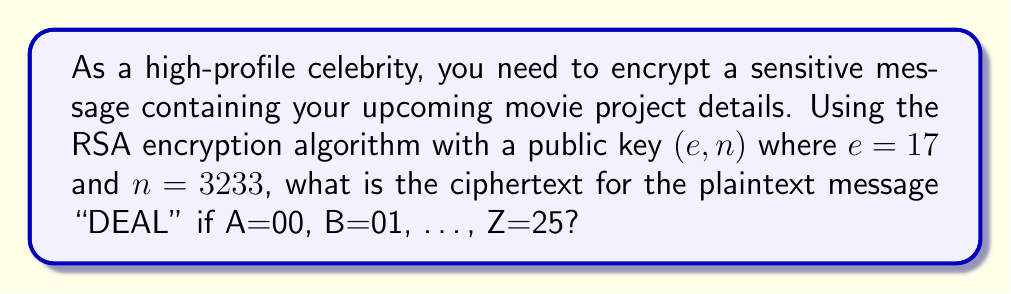Can you solve this math problem? 1. First, we need to convert the plaintext "DEAL" to numbers:
   D = 03, E = 04, A = 00, L = 11

2. We then combine these numbers into blocks of 4 digits each:
   0304 0011

3. The RSA encryption formula is $c \equiv m^e \pmod{n}$, where $c$ is the ciphertext, $m$ is the plaintext block, $e$ is the public exponent, and $n$ is the modulus.

4. For the first block (0304):
   $c_1 \equiv 304^{17} \pmod{3233}$
   $c_1 \equiv 2298 \pmod{3233}$

5. For the second block (0011):
   $c_2 \equiv 11^{17} \pmod{3233}$
   $c_2 \equiv 2816 \pmod{3233}$

6. The final ciphertext is the concatenation of these results:
   2298 2816
Answer: 2298 2816 